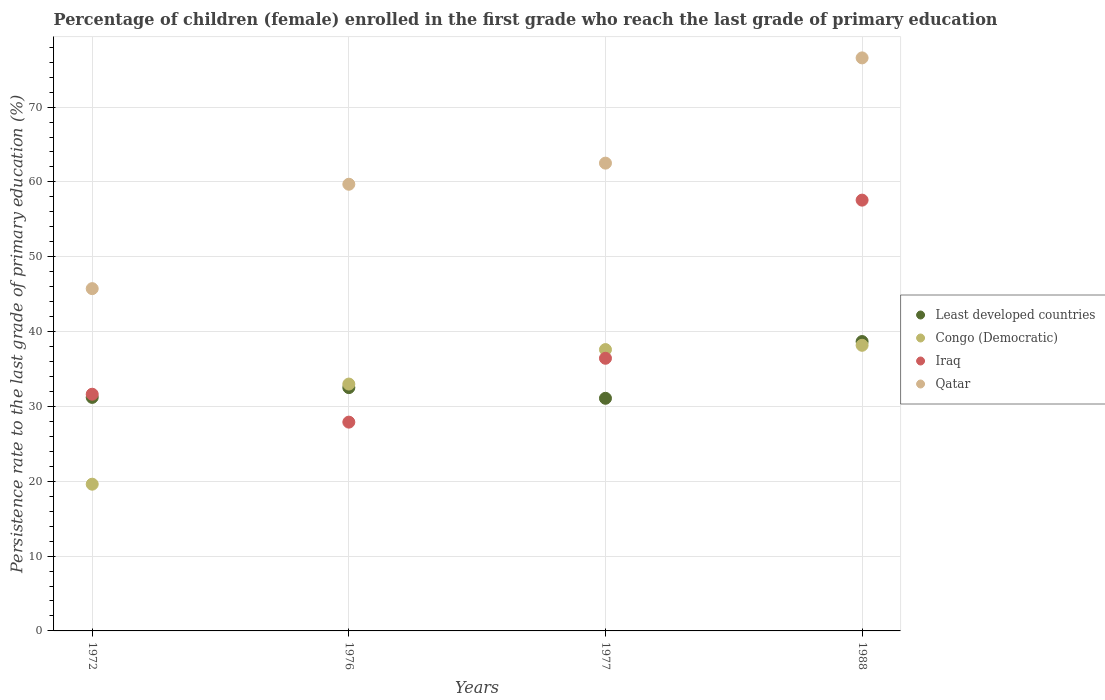How many different coloured dotlines are there?
Your answer should be very brief. 4. Is the number of dotlines equal to the number of legend labels?
Offer a very short reply. Yes. What is the persistence rate of children in Least developed countries in 1988?
Your answer should be compact. 38.67. Across all years, what is the maximum persistence rate of children in Qatar?
Offer a terse response. 76.57. Across all years, what is the minimum persistence rate of children in Qatar?
Offer a terse response. 45.74. In which year was the persistence rate of children in Qatar maximum?
Offer a terse response. 1988. In which year was the persistence rate of children in Iraq minimum?
Give a very brief answer. 1976. What is the total persistence rate of children in Congo (Democratic) in the graph?
Your answer should be very brief. 128.36. What is the difference between the persistence rate of children in Iraq in 1972 and that in 1976?
Make the answer very short. 3.73. What is the difference between the persistence rate of children in Congo (Democratic) in 1976 and the persistence rate of children in Least developed countries in 1977?
Your answer should be very brief. 1.9. What is the average persistence rate of children in Iraq per year?
Provide a short and direct response. 38.38. In the year 1976, what is the difference between the persistence rate of children in Congo (Democratic) and persistence rate of children in Iraq?
Ensure brevity in your answer.  5.09. What is the ratio of the persistence rate of children in Iraq in 1976 to that in 1977?
Your response must be concise. 0.77. Is the persistence rate of children in Iraq in 1976 less than that in 1988?
Your response must be concise. Yes. What is the difference between the highest and the second highest persistence rate of children in Qatar?
Your answer should be very brief. 14.06. What is the difference between the highest and the lowest persistence rate of children in Congo (Democratic)?
Give a very brief answer. 18.56. Is the sum of the persistence rate of children in Iraq in 1972 and 1988 greater than the maximum persistence rate of children in Congo (Democratic) across all years?
Offer a terse response. Yes. Is it the case that in every year, the sum of the persistence rate of children in Least developed countries and persistence rate of children in Congo (Democratic)  is greater than the sum of persistence rate of children in Qatar and persistence rate of children in Iraq?
Give a very brief answer. No. Is it the case that in every year, the sum of the persistence rate of children in Iraq and persistence rate of children in Congo (Democratic)  is greater than the persistence rate of children in Qatar?
Your response must be concise. Yes. Does the persistence rate of children in Congo (Democratic) monotonically increase over the years?
Give a very brief answer. Yes. Is the persistence rate of children in Least developed countries strictly greater than the persistence rate of children in Iraq over the years?
Keep it short and to the point. No. Is the persistence rate of children in Least developed countries strictly less than the persistence rate of children in Iraq over the years?
Provide a succinct answer. No. How many dotlines are there?
Your answer should be very brief. 4. Are the values on the major ticks of Y-axis written in scientific E-notation?
Provide a short and direct response. No. How many legend labels are there?
Give a very brief answer. 4. How are the legend labels stacked?
Keep it short and to the point. Vertical. What is the title of the graph?
Provide a succinct answer. Percentage of children (female) enrolled in the first grade who reach the last grade of primary education. Does "Cayman Islands" appear as one of the legend labels in the graph?
Your answer should be compact. No. What is the label or title of the X-axis?
Provide a short and direct response. Years. What is the label or title of the Y-axis?
Keep it short and to the point. Persistence rate to the last grade of primary education (%). What is the Persistence rate to the last grade of primary education (%) in Least developed countries in 1972?
Your answer should be very brief. 31.2. What is the Persistence rate to the last grade of primary education (%) in Congo (Democratic) in 1972?
Provide a succinct answer. 19.61. What is the Persistence rate to the last grade of primary education (%) of Iraq in 1972?
Make the answer very short. 31.63. What is the Persistence rate to the last grade of primary education (%) in Qatar in 1972?
Offer a terse response. 45.74. What is the Persistence rate to the last grade of primary education (%) in Least developed countries in 1976?
Your answer should be very brief. 32.51. What is the Persistence rate to the last grade of primary education (%) in Congo (Democratic) in 1976?
Give a very brief answer. 32.99. What is the Persistence rate to the last grade of primary education (%) in Iraq in 1976?
Your answer should be very brief. 27.9. What is the Persistence rate to the last grade of primary education (%) in Qatar in 1976?
Give a very brief answer. 59.69. What is the Persistence rate to the last grade of primary education (%) of Least developed countries in 1977?
Offer a terse response. 31.08. What is the Persistence rate to the last grade of primary education (%) of Congo (Democratic) in 1977?
Offer a very short reply. 37.59. What is the Persistence rate to the last grade of primary education (%) in Iraq in 1977?
Your answer should be compact. 36.43. What is the Persistence rate to the last grade of primary education (%) in Qatar in 1977?
Offer a terse response. 62.51. What is the Persistence rate to the last grade of primary education (%) of Least developed countries in 1988?
Offer a terse response. 38.67. What is the Persistence rate to the last grade of primary education (%) in Congo (Democratic) in 1988?
Provide a succinct answer. 38.17. What is the Persistence rate to the last grade of primary education (%) of Iraq in 1988?
Give a very brief answer. 57.56. What is the Persistence rate to the last grade of primary education (%) of Qatar in 1988?
Your answer should be compact. 76.57. Across all years, what is the maximum Persistence rate to the last grade of primary education (%) in Least developed countries?
Give a very brief answer. 38.67. Across all years, what is the maximum Persistence rate to the last grade of primary education (%) in Congo (Democratic)?
Provide a succinct answer. 38.17. Across all years, what is the maximum Persistence rate to the last grade of primary education (%) in Iraq?
Your answer should be very brief. 57.56. Across all years, what is the maximum Persistence rate to the last grade of primary education (%) of Qatar?
Your answer should be compact. 76.57. Across all years, what is the minimum Persistence rate to the last grade of primary education (%) in Least developed countries?
Give a very brief answer. 31.08. Across all years, what is the minimum Persistence rate to the last grade of primary education (%) of Congo (Democratic)?
Your response must be concise. 19.61. Across all years, what is the minimum Persistence rate to the last grade of primary education (%) of Iraq?
Your answer should be compact. 27.9. Across all years, what is the minimum Persistence rate to the last grade of primary education (%) in Qatar?
Your answer should be compact. 45.74. What is the total Persistence rate to the last grade of primary education (%) of Least developed countries in the graph?
Keep it short and to the point. 133.47. What is the total Persistence rate to the last grade of primary education (%) in Congo (Democratic) in the graph?
Offer a terse response. 128.36. What is the total Persistence rate to the last grade of primary education (%) of Iraq in the graph?
Offer a terse response. 153.53. What is the total Persistence rate to the last grade of primary education (%) in Qatar in the graph?
Your answer should be very brief. 244.5. What is the difference between the Persistence rate to the last grade of primary education (%) in Least developed countries in 1972 and that in 1976?
Provide a succinct answer. -1.31. What is the difference between the Persistence rate to the last grade of primary education (%) in Congo (Democratic) in 1972 and that in 1976?
Provide a succinct answer. -13.38. What is the difference between the Persistence rate to the last grade of primary education (%) in Iraq in 1972 and that in 1976?
Provide a short and direct response. 3.73. What is the difference between the Persistence rate to the last grade of primary education (%) of Qatar in 1972 and that in 1976?
Ensure brevity in your answer.  -13.95. What is the difference between the Persistence rate to the last grade of primary education (%) in Least developed countries in 1972 and that in 1977?
Provide a short and direct response. 0.12. What is the difference between the Persistence rate to the last grade of primary education (%) in Congo (Democratic) in 1972 and that in 1977?
Offer a terse response. -17.99. What is the difference between the Persistence rate to the last grade of primary education (%) in Iraq in 1972 and that in 1977?
Offer a terse response. -4.8. What is the difference between the Persistence rate to the last grade of primary education (%) in Qatar in 1972 and that in 1977?
Your response must be concise. -16.77. What is the difference between the Persistence rate to the last grade of primary education (%) of Least developed countries in 1972 and that in 1988?
Your answer should be very brief. -7.46. What is the difference between the Persistence rate to the last grade of primary education (%) of Congo (Democratic) in 1972 and that in 1988?
Your answer should be very brief. -18.56. What is the difference between the Persistence rate to the last grade of primary education (%) in Iraq in 1972 and that in 1988?
Your answer should be compact. -25.94. What is the difference between the Persistence rate to the last grade of primary education (%) in Qatar in 1972 and that in 1988?
Ensure brevity in your answer.  -30.83. What is the difference between the Persistence rate to the last grade of primary education (%) in Least developed countries in 1976 and that in 1977?
Keep it short and to the point. 1.43. What is the difference between the Persistence rate to the last grade of primary education (%) in Congo (Democratic) in 1976 and that in 1977?
Provide a short and direct response. -4.61. What is the difference between the Persistence rate to the last grade of primary education (%) of Iraq in 1976 and that in 1977?
Offer a very short reply. -8.53. What is the difference between the Persistence rate to the last grade of primary education (%) in Qatar in 1976 and that in 1977?
Provide a short and direct response. -2.82. What is the difference between the Persistence rate to the last grade of primary education (%) in Least developed countries in 1976 and that in 1988?
Your answer should be very brief. -6.16. What is the difference between the Persistence rate to the last grade of primary education (%) of Congo (Democratic) in 1976 and that in 1988?
Offer a very short reply. -5.18. What is the difference between the Persistence rate to the last grade of primary education (%) of Iraq in 1976 and that in 1988?
Give a very brief answer. -29.66. What is the difference between the Persistence rate to the last grade of primary education (%) in Qatar in 1976 and that in 1988?
Offer a terse response. -16.89. What is the difference between the Persistence rate to the last grade of primary education (%) in Least developed countries in 1977 and that in 1988?
Give a very brief answer. -7.58. What is the difference between the Persistence rate to the last grade of primary education (%) in Congo (Democratic) in 1977 and that in 1988?
Your response must be concise. -0.57. What is the difference between the Persistence rate to the last grade of primary education (%) of Iraq in 1977 and that in 1988?
Ensure brevity in your answer.  -21.13. What is the difference between the Persistence rate to the last grade of primary education (%) of Qatar in 1977 and that in 1988?
Your answer should be very brief. -14.06. What is the difference between the Persistence rate to the last grade of primary education (%) in Least developed countries in 1972 and the Persistence rate to the last grade of primary education (%) in Congo (Democratic) in 1976?
Your answer should be very brief. -1.78. What is the difference between the Persistence rate to the last grade of primary education (%) in Least developed countries in 1972 and the Persistence rate to the last grade of primary education (%) in Iraq in 1976?
Offer a very short reply. 3.3. What is the difference between the Persistence rate to the last grade of primary education (%) of Least developed countries in 1972 and the Persistence rate to the last grade of primary education (%) of Qatar in 1976?
Provide a short and direct response. -28.48. What is the difference between the Persistence rate to the last grade of primary education (%) of Congo (Democratic) in 1972 and the Persistence rate to the last grade of primary education (%) of Iraq in 1976?
Keep it short and to the point. -8.29. What is the difference between the Persistence rate to the last grade of primary education (%) in Congo (Democratic) in 1972 and the Persistence rate to the last grade of primary education (%) in Qatar in 1976?
Keep it short and to the point. -40.08. What is the difference between the Persistence rate to the last grade of primary education (%) of Iraq in 1972 and the Persistence rate to the last grade of primary education (%) of Qatar in 1976?
Your answer should be very brief. -28.06. What is the difference between the Persistence rate to the last grade of primary education (%) in Least developed countries in 1972 and the Persistence rate to the last grade of primary education (%) in Congo (Democratic) in 1977?
Offer a very short reply. -6.39. What is the difference between the Persistence rate to the last grade of primary education (%) of Least developed countries in 1972 and the Persistence rate to the last grade of primary education (%) of Iraq in 1977?
Ensure brevity in your answer.  -5.23. What is the difference between the Persistence rate to the last grade of primary education (%) of Least developed countries in 1972 and the Persistence rate to the last grade of primary education (%) of Qatar in 1977?
Offer a very short reply. -31.3. What is the difference between the Persistence rate to the last grade of primary education (%) in Congo (Democratic) in 1972 and the Persistence rate to the last grade of primary education (%) in Iraq in 1977?
Keep it short and to the point. -16.83. What is the difference between the Persistence rate to the last grade of primary education (%) in Congo (Democratic) in 1972 and the Persistence rate to the last grade of primary education (%) in Qatar in 1977?
Your answer should be compact. -42.9. What is the difference between the Persistence rate to the last grade of primary education (%) in Iraq in 1972 and the Persistence rate to the last grade of primary education (%) in Qatar in 1977?
Make the answer very short. -30.88. What is the difference between the Persistence rate to the last grade of primary education (%) of Least developed countries in 1972 and the Persistence rate to the last grade of primary education (%) of Congo (Democratic) in 1988?
Provide a succinct answer. -6.96. What is the difference between the Persistence rate to the last grade of primary education (%) of Least developed countries in 1972 and the Persistence rate to the last grade of primary education (%) of Iraq in 1988?
Your answer should be compact. -26.36. What is the difference between the Persistence rate to the last grade of primary education (%) of Least developed countries in 1972 and the Persistence rate to the last grade of primary education (%) of Qatar in 1988?
Keep it short and to the point. -45.37. What is the difference between the Persistence rate to the last grade of primary education (%) in Congo (Democratic) in 1972 and the Persistence rate to the last grade of primary education (%) in Iraq in 1988?
Provide a short and direct response. -37.96. What is the difference between the Persistence rate to the last grade of primary education (%) of Congo (Democratic) in 1972 and the Persistence rate to the last grade of primary education (%) of Qatar in 1988?
Provide a short and direct response. -56.96. What is the difference between the Persistence rate to the last grade of primary education (%) in Iraq in 1972 and the Persistence rate to the last grade of primary education (%) in Qatar in 1988?
Offer a very short reply. -44.94. What is the difference between the Persistence rate to the last grade of primary education (%) of Least developed countries in 1976 and the Persistence rate to the last grade of primary education (%) of Congo (Democratic) in 1977?
Provide a succinct answer. -5.08. What is the difference between the Persistence rate to the last grade of primary education (%) of Least developed countries in 1976 and the Persistence rate to the last grade of primary education (%) of Iraq in 1977?
Make the answer very short. -3.92. What is the difference between the Persistence rate to the last grade of primary education (%) in Least developed countries in 1976 and the Persistence rate to the last grade of primary education (%) in Qatar in 1977?
Make the answer very short. -30. What is the difference between the Persistence rate to the last grade of primary education (%) in Congo (Democratic) in 1976 and the Persistence rate to the last grade of primary education (%) in Iraq in 1977?
Offer a very short reply. -3.45. What is the difference between the Persistence rate to the last grade of primary education (%) of Congo (Democratic) in 1976 and the Persistence rate to the last grade of primary education (%) of Qatar in 1977?
Give a very brief answer. -29.52. What is the difference between the Persistence rate to the last grade of primary education (%) in Iraq in 1976 and the Persistence rate to the last grade of primary education (%) in Qatar in 1977?
Provide a short and direct response. -34.61. What is the difference between the Persistence rate to the last grade of primary education (%) in Least developed countries in 1976 and the Persistence rate to the last grade of primary education (%) in Congo (Democratic) in 1988?
Your response must be concise. -5.66. What is the difference between the Persistence rate to the last grade of primary education (%) in Least developed countries in 1976 and the Persistence rate to the last grade of primary education (%) in Iraq in 1988?
Ensure brevity in your answer.  -25.05. What is the difference between the Persistence rate to the last grade of primary education (%) in Least developed countries in 1976 and the Persistence rate to the last grade of primary education (%) in Qatar in 1988?
Your answer should be compact. -44.06. What is the difference between the Persistence rate to the last grade of primary education (%) of Congo (Democratic) in 1976 and the Persistence rate to the last grade of primary education (%) of Iraq in 1988?
Offer a terse response. -24.58. What is the difference between the Persistence rate to the last grade of primary education (%) of Congo (Democratic) in 1976 and the Persistence rate to the last grade of primary education (%) of Qatar in 1988?
Keep it short and to the point. -43.58. What is the difference between the Persistence rate to the last grade of primary education (%) of Iraq in 1976 and the Persistence rate to the last grade of primary education (%) of Qatar in 1988?
Provide a succinct answer. -48.67. What is the difference between the Persistence rate to the last grade of primary education (%) of Least developed countries in 1977 and the Persistence rate to the last grade of primary education (%) of Congo (Democratic) in 1988?
Provide a succinct answer. -7.08. What is the difference between the Persistence rate to the last grade of primary education (%) in Least developed countries in 1977 and the Persistence rate to the last grade of primary education (%) in Iraq in 1988?
Keep it short and to the point. -26.48. What is the difference between the Persistence rate to the last grade of primary education (%) of Least developed countries in 1977 and the Persistence rate to the last grade of primary education (%) of Qatar in 1988?
Provide a succinct answer. -45.49. What is the difference between the Persistence rate to the last grade of primary education (%) in Congo (Democratic) in 1977 and the Persistence rate to the last grade of primary education (%) in Iraq in 1988?
Offer a very short reply. -19.97. What is the difference between the Persistence rate to the last grade of primary education (%) of Congo (Democratic) in 1977 and the Persistence rate to the last grade of primary education (%) of Qatar in 1988?
Offer a very short reply. -38.98. What is the difference between the Persistence rate to the last grade of primary education (%) in Iraq in 1977 and the Persistence rate to the last grade of primary education (%) in Qatar in 1988?
Offer a terse response. -40.14. What is the average Persistence rate to the last grade of primary education (%) in Least developed countries per year?
Keep it short and to the point. 33.37. What is the average Persistence rate to the last grade of primary education (%) of Congo (Democratic) per year?
Ensure brevity in your answer.  32.09. What is the average Persistence rate to the last grade of primary education (%) in Iraq per year?
Provide a short and direct response. 38.38. What is the average Persistence rate to the last grade of primary education (%) in Qatar per year?
Your answer should be very brief. 61.13. In the year 1972, what is the difference between the Persistence rate to the last grade of primary education (%) of Least developed countries and Persistence rate to the last grade of primary education (%) of Congo (Democratic)?
Keep it short and to the point. 11.6. In the year 1972, what is the difference between the Persistence rate to the last grade of primary education (%) in Least developed countries and Persistence rate to the last grade of primary education (%) in Iraq?
Ensure brevity in your answer.  -0.43. In the year 1972, what is the difference between the Persistence rate to the last grade of primary education (%) in Least developed countries and Persistence rate to the last grade of primary education (%) in Qatar?
Offer a very short reply. -14.53. In the year 1972, what is the difference between the Persistence rate to the last grade of primary education (%) in Congo (Democratic) and Persistence rate to the last grade of primary education (%) in Iraq?
Provide a short and direct response. -12.02. In the year 1972, what is the difference between the Persistence rate to the last grade of primary education (%) in Congo (Democratic) and Persistence rate to the last grade of primary education (%) in Qatar?
Offer a very short reply. -26.13. In the year 1972, what is the difference between the Persistence rate to the last grade of primary education (%) of Iraq and Persistence rate to the last grade of primary education (%) of Qatar?
Provide a succinct answer. -14.11. In the year 1976, what is the difference between the Persistence rate to the last grade of primary education (%) of Least developed countries and Persistence rate to the last grade of primary education (%) of Congo (Democratic)?
Provide a short and direct response. -0.48. In the year 1976, what is the difference between the Persistence rate to the last grade of primary education (%) of Least developed countries and Persistence rate to the last grade of primary education (%) of Iraq?
Your answer should be compact. 4.61. In the year 1976, what is the difference between the Persistence rate to the last grade of primary education (%) of Least developed countries and Persistence rate to the last grade of primary education (%) of Qatar?
Provide a short and direct response. -27.17. In the year 1976, what is the difference between the Persistence rate to the last grade of primary education (%) of Congo (Democratic) and Persistence rate to the last grade of primary education (%) of Iraq?
Offer a terse response. 5.09. In the year 1976, what is the difference between the Persistence rate to the last grade of primary education (%) in Congo (Democratic) and Persistence rate to the last grade of primary education (%) in Qatar?
Offer a terse response. -26.7. In the year 1976, what is the difference between the Persistence rate to the last grade of primary education (%) in Iraq and Persistence rate to the last grade of primary education (%) in Qatar?
Offer a very short reply. -31.79. In the year 1977, what is the difference between the Persistence rate to the last grade of primary education (%) in Least developed countries and Persistence rate to the last grade of primary education (%) in Congo (Democratic)?
Offer a very short reply. -6.51. In the year 1977, what is the difference between the Persistence rate to the last grade of primary education (%) in Least developed countries and Persistence rate to the last grade of primary education (%) in Iraq?
Provide a succinct answer. -5.35. In the year 1977, what is the difference between the Persistence rate to the last grade of primary education (%) in Least developed countries and Persistence rate to the last grade of primary education (%) in Qatar?
Offer a terse response. -31.42. In the year 1977, what is the difference between the Persistence rate to the last grade of primary education (%) of Congo (Democratic) and Persistence rate to the last grade of primary education (%) of Iraq?
Offer a terse response. 1.16. In the year 1977, what is the difference between the Persistence rate to the last grade of primary education (%) in Congo (Democratic) and Persistence rate to the last grade of primary education (%) in Qatar?
Your response must be concise. -24.91. In the year 1977, what is the difference between the Persistence rate to the last grade of primary education (%) in Iraq and Persistence rate to the last grade of primary education (%) in Qatar?
Make the answer very short. -26.07. In the year 1988, what is the difference between the Persistence rate to the last grade of primary education (%) in Least developed countries and Persistence rate to the last grade of primary education (%) in Congo (Democratic)?
Your answer should be compact. 0.5. In the year 1988, what is the difference between the Persistence rate to the last grade of primary education (%) in Least developed countries and Persistence rate to the last grade of primary education (%) in Iraq?
Your response must be concise. -18.9. In the year 1988, what is the difference between the Persistence rate to the last grade of primary education (%) of Least developed countries and Persistence rate to the last grade of primary education (%) of Qatar?
Provide a succinct answer. -37.9. In the year 1988, what is the difference between the Persistence rate to the last grade of primary education (%) in Congo (Democratic) and Persistence rate to the last grade of primary education (%) in Iraq?
Ensure brevity in your answer.  -19.4. In the year 1988, what is the difference between the Persistence rate to the last grade of primary education (%) in Congo (Democratic) and Persistence rate to the last grade of primary education (%) in Qatar?
Keep it short and to the point. -38.4. In the year 1988, what is the difference between the Persistence rate to the last grade of primary education (%) of Iraq and Persistence rate to the last grade of primary education (%) of Qatar?
Your answer should be very brief. -19.01. What is the ratio of the Persistence rate to the last grade of primary education (%) of Least developed countries in 1972 to that in 1976?
Offer a very short reply. 0.96. What is the ratio of the Persistence rate to the last grade of primary education (%) of Congo (Democratic) in 1972 to that in 1976?
Your answer should be compact. 0.59. What is the ratio of the Persistence rate to the last grade of primary education (%) of Iraq in 1972 to that in 1976?
Offer a terse response. 1.13. What is the ratio of the Persistence rate to the last grade of primary education (%) in Qatar in 1972 to that in 1976?
Your answer should be very brief. 0.77. What is the ratio of the Persistence rate to the last grade of primary education (%) in Congo (Democratic) in 1972 to that in 1977?
Your response must be concise. 0.52. What is the ratio of the Persistence rate to the last grade of primary education (%) of Iraq in 1972 to that in 1977?
Give a very brief answer. 0.87. What is the ratio of the Persistence rate to the last grade of primary education (%) of Qatar in 1972 to that in 1977?
Ensure brevity in your answer.  0.73. What is the ratio of the Persistence rate to the last grade of primary education (%) in Least developed countries in 1972 to that in 1988?
Keep it short and to the point. 0.81. What is the ratio of the Persistence rate to the last grade of primary education (%) of Congo (Democratic) in 1972 to that in 1988?
Offer a terse response. 0.51. What is the ratio of the Persistence rate to the last grade of primary education (%) of Iraq in 1972 to that in 1988?
Give a very brief answer. 0.55. What is the ratio of the Persistence rate to the last grade of primary education (%) of Qatar in 1972 to that in 1988?
Make the answer very short. 0.6. What is the ratio of the Persistence rate to the last grade of primary education (%) of Least developed countries in 1976 to that in 1977?
Provide a succinct answer. 1.05. What is the ratio of the Persistence rate to the last grade of primary education (%) of Congo (Democratic) in 1976 to that in 1977?
Your answer should be very brief. 0.88. What is the ratio of the Persistence rate to the last grade of primary education (%) of Iraq in 1976 to that in 1977?
Keep it short and to the point. 0.77. What is the ratio of the Persistence rate to the last grade of primary education (%) in Qatar in 1976 to that in 1977?
Make the answer very short. 0.95. What is the ratio of the Persistence rate to the last grade of primary education (%) of Least developed countries in 1976 to that in 1988?
Your answer should be very brief. 0.84. What is the ratio of the Persistence rate to the last grade of primary education (%) of Congo (Democratic) in 1976 to that in 1988?
Your response must be concise. 0.86. What is the ratio of the Persistence rate to the last grade of primary education (%) of Iraq in 1976 to that in 1988?
Keep it short and to the point. 0.48. What is the ratio of the Persistence rate to the last grade of primary education (%) in Qatar in 1976 to that in 1988?
Your response must be concise. 0.78. What is the ratio of the Persistence rate to the last grade of primary education (%) in Least developed countries in 1977 to that in 1988?
Offer a terse response. 0.8. What is the ratio of the Persistence rate to the last grade of primary education (%) of Iraq in 1977 to that in 1988?
Offer a very short reply. 0.63. What is the ratio of the Persistence rate to the last grade of primary education (%) in Qatar in 1977 to that in 1988?
Your answer should be compact. 0.82. What is the difference between the highest and the second highest Persistence rate to the last grade of primary education (%) in Least developed countries?
Keep it short and to the point. 6.16. What is the difference between the highest and the second highest Persistence rate to the last grade of primary education (%) in Congo (Democratic)?
Offer a very short reply. 0.57. What is the difference between the highest and the second highest Persistence rate to the last grade of primary education (%) of Iraq?
Keep it short and to the point. 21.13. What is the difference between the highest and the second highest Persistence rate to the last grade of primary education (%) in Qatar?
Your answer should be compact. 14.06. What is the difference between the highest and the lowest Persistence rate to the last grade of primary education (%) in Least developed countries?
Make the answer very short. 7.58. What is the difference between the highest and the lowest Persistence rate to the last grade of primary education (%) of Congo (Democratic)?
Ensure brevity in your answer.  18.56. What is the difference between the highest and the lowest Persistence rate to the last grade of primary education (%) of Iraq?
Ensure brevity in your answer.  29.66. What is the difference between the highest and the lowest Persistence rate to the last grade of primary education (%) of Qatar?
Your response must be concise. 30.83. 